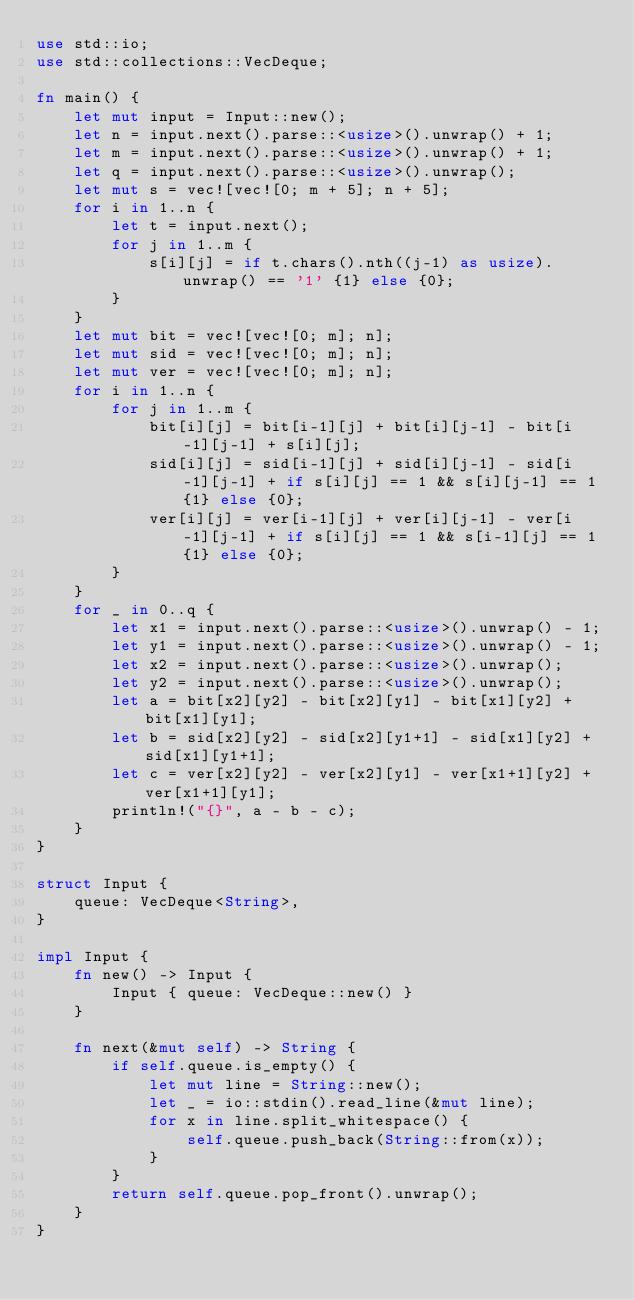Convert code to text. <code><loc_0><loc_0><loc_500><loc_500><_Rust_>use std::io;
use std::collections::VecDeque;

fn main() {
    let mut input = Input::new();
    let n = input.next().parse::<usize>().unwrap() + 1;
    let m = input.next().parse::<usize>().unwrap() + 1;
    let q = input.next().parse::<usize>().unwrap();
    let mut s = vec![vec![0; m + 5]; n + 5];
    for i in 1..n {
        let t = input.next();
        for j in 1..m {
            s[i][j] = if t.chars().nth((j-1) as usize).unwrap() == '1' {1} else {0};
        }
    }
    let mut bit = vec![vec![0; m]; n];
    let mut sid = vec![vec![0; m]; n];
    let mut ver = vec![vec![0; m]; n];
    for i in 1..n {
        for j in 1..m {
            bit[i][j] = bit[i-1][j] + bit[i][j-1] - bit[i-1][j-1] + s[i][j];
            sid[i][j] = sid[i-1][j] + sid[i][j-1] - sid[i-1][j-1] + if s[i][j] == 1 && s[i][j-1] == 1 {1} else {0};
            ver[i][j] = ver[i-1][j] + ver[i][j-1] - ver[i-1][j-1] + if s[i][j] == 1 && s[i-1][j] == 1 {1} else {0};
        }
    }
    for _ in 0..q {
        let x1 = input.next().parse::<usize>().unwrap() - 1;
        let y1 = input.next().parse::<usize>().unwrap() - 1;
        let x2 = input.next().parse::<usize>().unwrap();
        let y2 = input.next().parse::<usize>().unwrap();
        let a = bit[x2][y2] - bit[x2][y1] - bit[x1][y2] + bit[x1][y1];
        let b = sid[x2][y2] - sid[x2][y1+1] - sid[x1][y2] + sid[x1][y1+1];
        let c = ver[x2][y2] - ver[x2][y1] - ver[x1+1][y2] + ver[x1+1][y1];
        println!("{}", a - b - c);
    }
}

struct Input {
    queue: VecDeque<String>,
}

impl Input {
    fn new() -> Input {
        Input { queue: VecDeque::new() }
    }

    fn next(&mut self) -> String {
        if self.queue.is_empty() {
            let mut line = String::new();
            let _ = io::stdin().read_line(&mut line);
            for x in line.split_whitespace() {
                self.queue.push_back(String::from(x));
            }
        }
        return self.queue.pop_front().unwrap();
    }
}

</code> 